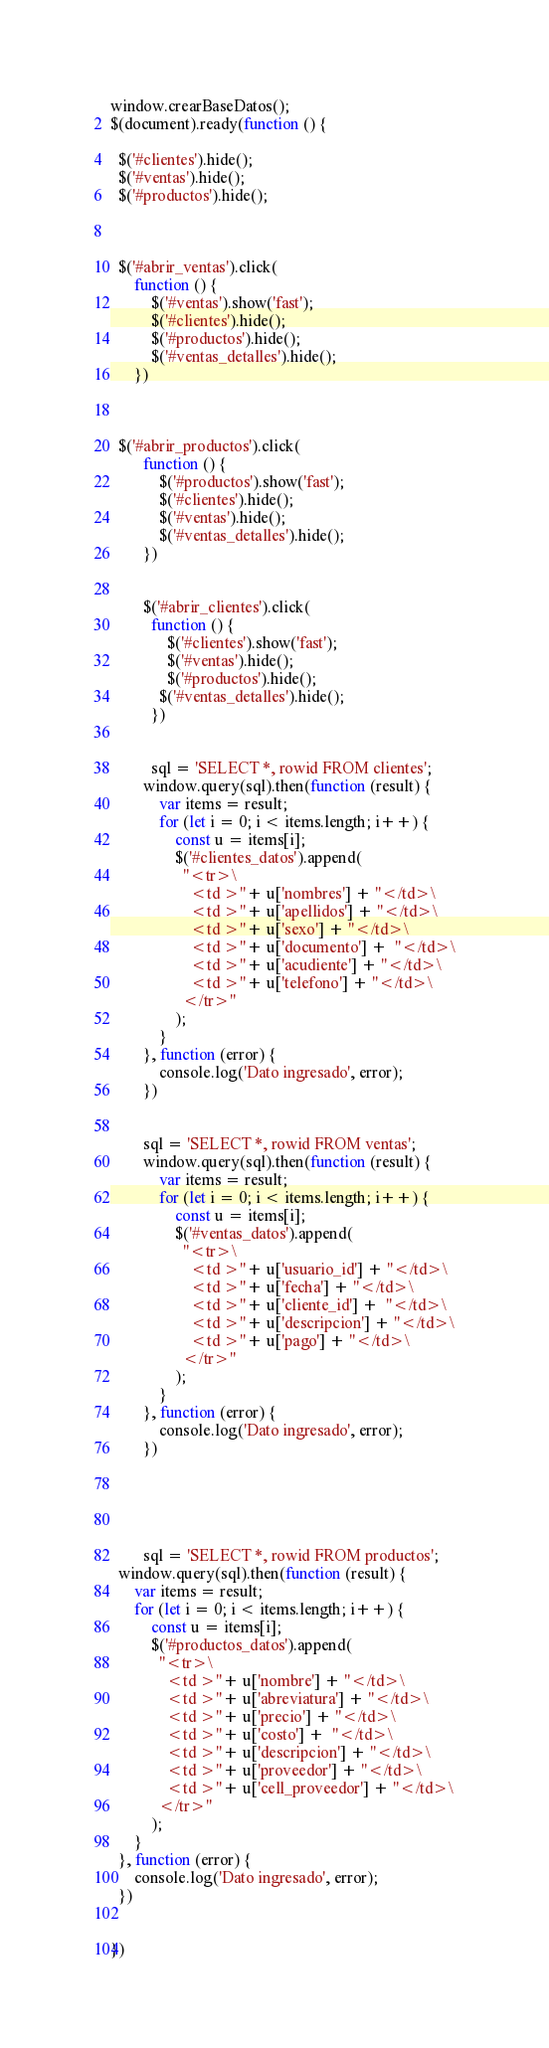<code> <loc_0><loc_0><loc_500><loc_500><_JavaScript_>window.crearBaseDatos();
$(document).ready(function () {
 
  $('#clientes').hide();
  $('#ventas').hide();
  $('#productos').hide();

  

  $('#abrir_ventas').click(
      function () {
          $('#ventas').show('fast');
          $('#clientes').hide();
          $('#productos').hide();
          $('#ventas_detalles').hide();
      })
  
  

  $('#abrir_productos').click(
        function () {
            $('#productos').show('fast');
            $('#clientes').hide();
            $('#ventas').hide();
            $('#ventas_detalles').hide();
        })


        $('#abrir_clientes').click(
          function () {
              $('#clientes').show('fast');
              $('#ventas').hide();
              $('#productos').hide();
            $('#ventas_detalles').hide();
          })


          sql = 'SELECT *, rowid FROM clientes';
        window.query(sql).then(function (result) {
            var items = result;
            for (let i = 0; i < items.length; i++) {
                const u = items[i];
                $('#clientes_datos').append(
                  "<tr>\
                    <td >"+ u['nombres'] + "</td>\
                    <td >"+ u['apellidos'] + "</td>\
                    <td >"+ u['sexo'] + "</td>\
                    <td >"+ u['documento'] +  "</td>\
                    <td >"+ u['acudiente'] + "</td>\
                    <td >"+ u['telefono'] + "</td>\
                  </tr>"
                );
            }
        }, function (error) {
            console.log('Dato ingresado', error);
        })


        sql = 'SELECT *, rowid FROM ventas';
        window.query(sql).then(function (result) {
            var items = result;
            for (let i = 0; i < items.length; i++) {
                const u = items[i];
                $('#ventas_datos').append(
                  "<tr>\
                    <td >"+ u['usuario_id'] + "</td>\
                    <td >"+ u['fecha'] + "</td>\
                    <td >"+ u['cliente_id'] +  "</td>\
                    <td >"+ u['descripcion'] + "</td>\
                    <td >"+ u['pago'] + "</td>\
                  </tr>"
                );
            }
        }, function (error) {
            console.log('Dato ingresado', error);
        })





        sql = 'SELECT *, rowid FROM productos';
  window.query(sql).then(function (result) {
      var items = result;
      for (let i = 0; i < items.length; i++) {
          const u = items[i];
          $('#productos_datos').append(
            "<tr>\
              <td >"+ u['nombre'] + "</td>\
              <td >"+ u['abreviatura'] + "</td>\
              <td >"+ u['precio'] + "</td>\
              <td >"+ u['costo'] +  "</td>\
              <td >"+ u['descripcion'] + "</td>\
              <td >"+ u['proveedor'] + "</td>\
              <td >"+ u['cell_proveedor'] + "</td>\
            </tr>"
          );
      }
  }, function (error) {
      console.log('Dato ingresado', error);
  })

  
})</code> 